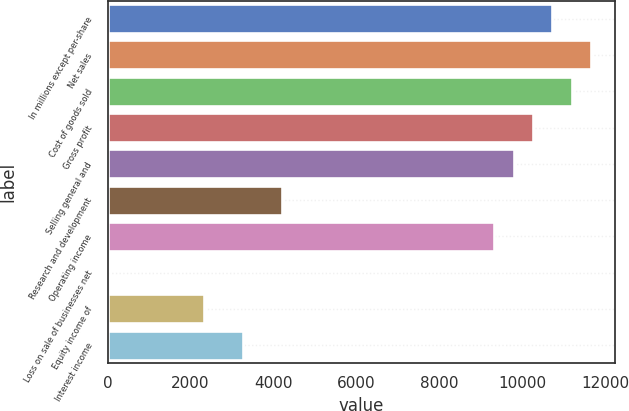Convert chart to OTSL. <chart><loc_0><loc_0><loc_500><loc_500><bar_chart><fcel>In millions except per-share<fcel>Net sales<fcel>Cost of goods sold<fcel>Gross profit<fcel>Selling general and<fcel>Research and development<fcel>Operating income<fcel>Loss on sale of businesses net<fcel>Equity income of<fcel>Interest income<nl><fcel>10733.4<fcel>11666.7<fcel>11200<fcel>10266.7<fcel>9800.06<fcel>4200.14<fcel>9333.4<fcel>0.2<fcel>2333.5<fcel>3266.82<nl></chart> 